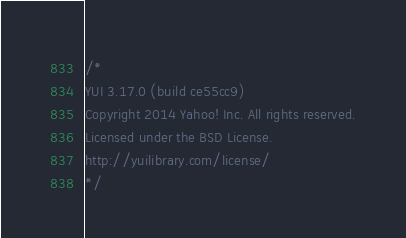Convert code to text. <code><loc_0><loc_0><loc_500><loc_500><_CSS_>/*
YUI 3.17.0 (build ce55cc9)
Copyright 2014 Yahoo! Inc. All rights reserved.
Licensed under the BSD License.
http://yuilibrary.com/license/
*/
</code> 